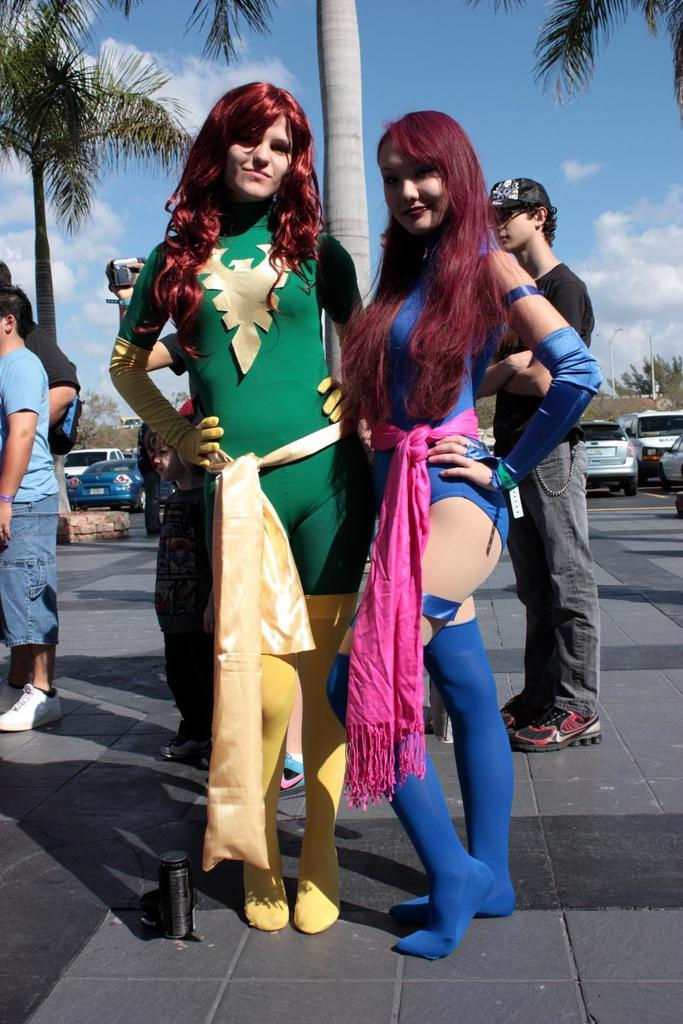What can be seen in the image? There are people standing in the image. Can you describe the people in the front of the group? Women are in the front of the group. What are the women wearing? The women are wearing costumes. How are the women feeling in the image? The women are smiling. What can be seen in the background of the image? There are trees and the sky visible in the background. What type of bean is being roasted by the machine in the image? There is no bean or machine present in the image. How does the burn on the woman's hand look in the image? There is no burn visible on any of the women in the image. 